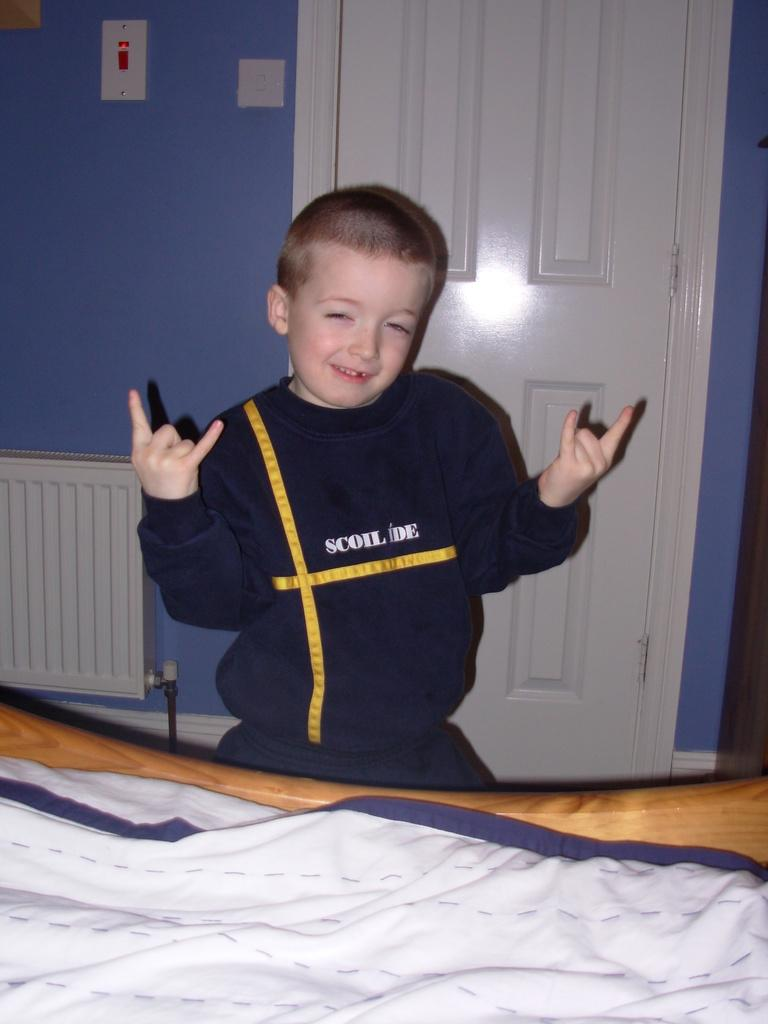<image>
Offer a succinct explanation of the picture presented. a boy in a Scoil Ide shirt with devil horn hands 